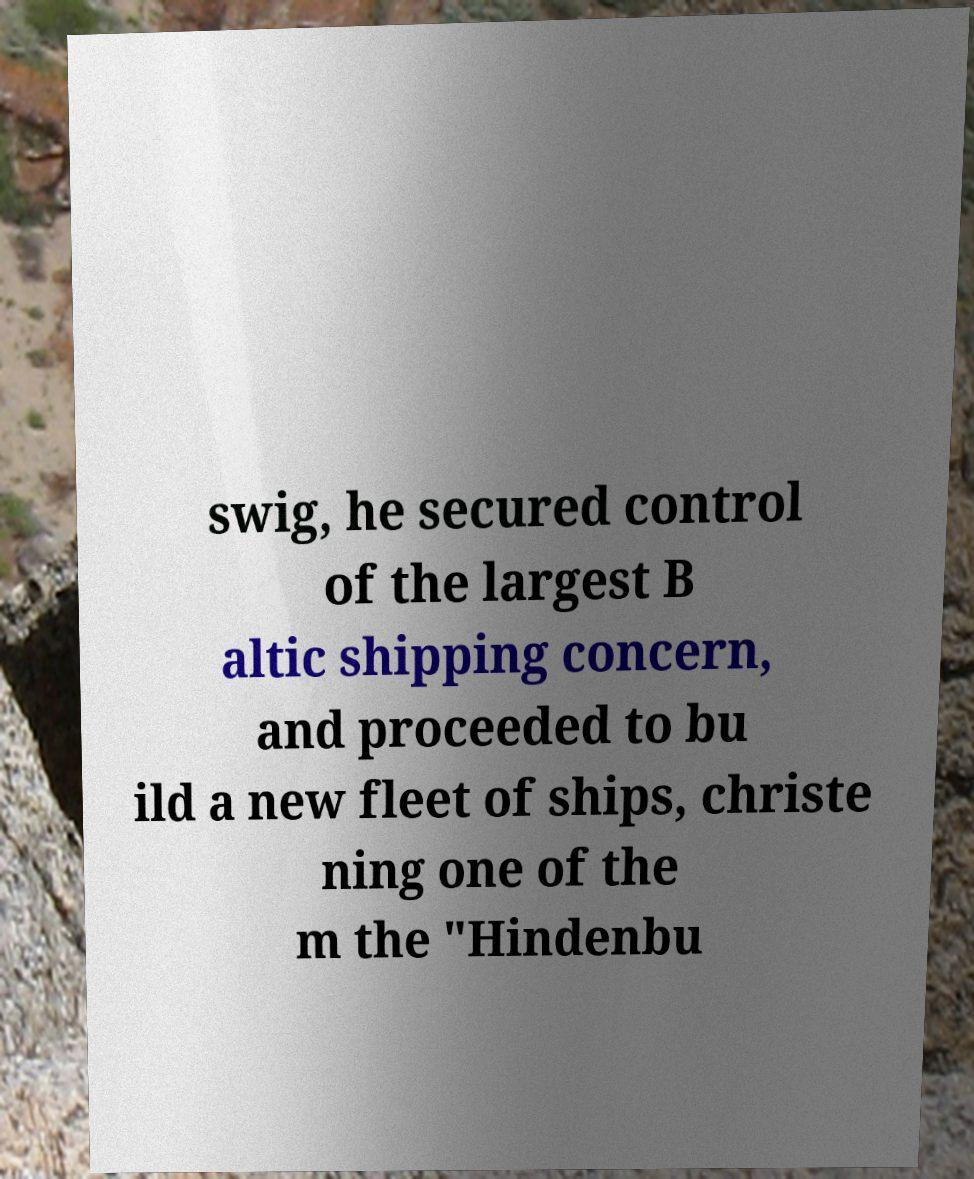Please read and relay the text visible in this image. What does it say? swig, he secured control of the largest B altic shipping concern, and proceeded to bu ild a new fleet of ships, christe ning one of the m the "Hindenbu 